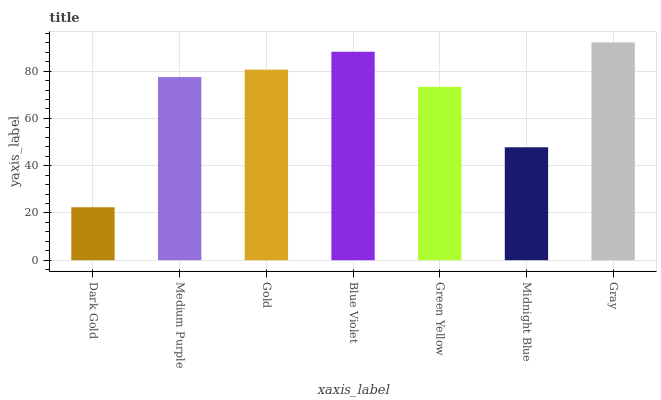Is Dark Gold the minimum?
Answer yes or no. Yes. Is Gray the maximum?
Answer yes or no. Yes. Is Medium Purple the minimum?
Answer yes or no. No. Is Medium Purple the maximum?
Answer yes or no. No. Is Medium Purple greater than Dark Gold?
Answer yes or no. Yes. Is Dark Gold less than Medium Purple?
Answer yes or no. Yes. Is Dark Gold greater than Medium Purple?
Answer yes or no. No. Is Medium Purple less than Dark Gold?
Answer yes or no. No. Is Medium Purple the high median?
Answer yes or no. Yes. Is Medium Purple the low median?
Answer yes or no. Yes. Is Midnight Blue the high median?
Answer yes or no. No. Is Dark Gold the low median?
Answer yes or no. No. 